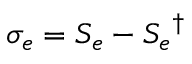Convert formula to latex. <formula><loc_0><loc_0><loc_500><loc_500>\sigma _ { e } = S _ { e } - { S _ { e } } ^ { \dagger }</formula> 